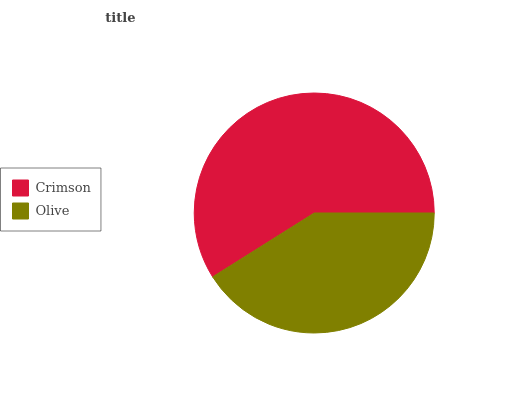Is Olive the minimum?
Answer yes or no. Yes. Is Crimson the maximum?
Answer yes or no. Yes. Is Olive the maximum?
Answer yes or no. No. Is Crimson greater than Olive?
Answer yes or no. Yes. Is Olive less than Crimson?
Answer yes or no. Yes. Is Olive greater than Crimson?
Answer yes or no. No. Is Crimson less than Olive?
Answer yes or no. No. Is Crimson the high median?
Answer yes or no. Yes. Is Olive the low median?
Answer yes or no. Yes. Is Olive the high median?
Answer yes or no. No. Is Crimson the low median?
Answer yes or no. No. 